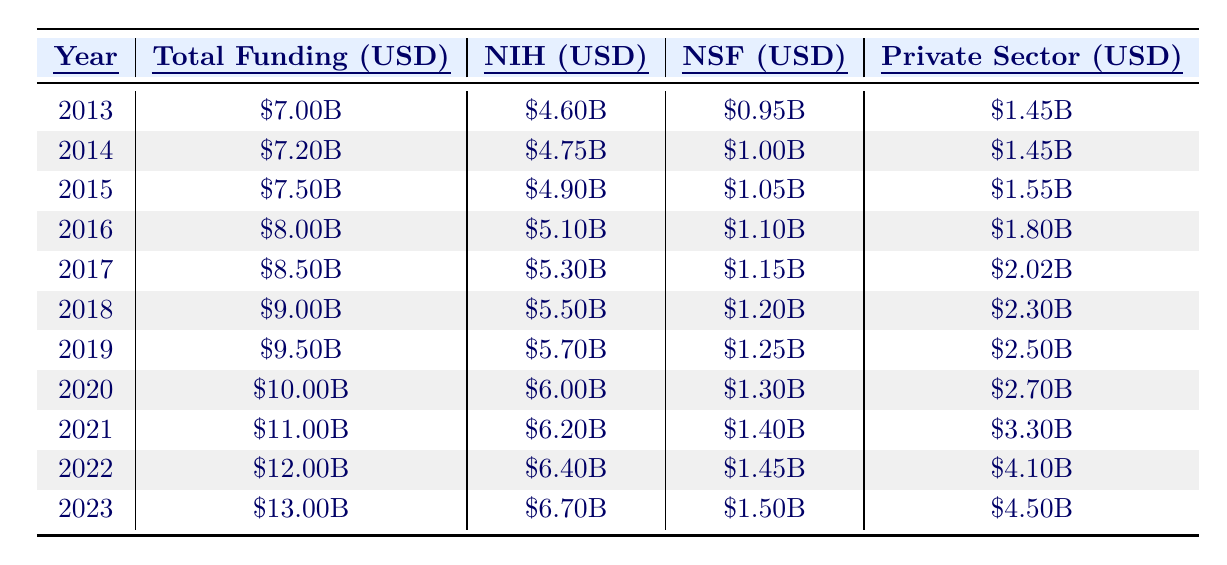What was the total funding for neuroscience research in 2015? The table shows that in 2015, the total funding was listed as \$7.50 billion.
Answer: \$7.50 billion Which funding source contributed the most in 2020? The NIH (National Institutes of Health) contributed \$6.00 billion in 2020, which is more than the contributions from NSF and the Private Sector.
Answer: NIH What is the percentage increase in total funding from 2013 to 2023? The total funding in 2013 was \$7.00 billion and in 2023 it is \$13.00 billion. The increase is \$13.00B - \$7.00B = \$6.00B. The percentage increase is (\$6.00B / \$7.00B) * 100 = 85.71%.
Answer: 85.71% In which year did the Private Sector funding exceed \$2 billion? The table indicates that Private Sector funding surpassed \$2 billion for the first time in 2017, as the amounts for years before that were below \$2 billion.
Answer: 2017 What was the average total funding over the 11 years from 2013 to 2023? The sum of total funding from 2013 to 2023 is \$7.00B + \$7.20B + \$7.50B + \$8.00B + \$8.50B + \$9.00B + \$9.50B + \$10.00B + \$11.00B + \$12.00B + \$13.00B = \$98.70 billion. The average is \$98.70B / 11 ≈ \$8.97 billion.
Answer: Approximately \$8.97 billion Was there an increase in NIH funding from 2019 to 2022? Yes, NIH funding in 2019 was \$5.70 billion and in 2022 it increased to \$6.40 billion, indicating a positive change.
Answer: Yes What was the total amount funded by NSF in 2021 and 2022 combined? For 2021, NSF funding was \$1.40 billion, and for 2022 it was \$1.45 billion. The combined total is \$1.40B + \$1.45B = \$2.85 billion.
Answer: \$2.85 billion How much did total funding increase from 2021 to 2023? The total funding in 2021 was \$11.00 billion and in 2023 it is \$13.00 billion. The increase is \$13.00B - \$11.00B = \$2.00B.
Answer: \$2.00 billion Which year had the highest contribution from the Private Sector, and what was the amount? The year 2023 had the highest Private Sector contribution of \$4.50 billion. Prior years had lower amounts.
Answer: 2023, \$4.50 billion What is the average funding from the NIH over the years 2013 to 2023? The NIH funding amounts are \$4.60B, \$4.75B, \$4.90B, \$5.10B, \$5.30B, \$5.50B, \$5.70B, \$6.00B, \$6.20B, \$6.40B, and \$6.70B, summing to \$57.10B. The average is \$57.10B / 11 ≈ \$5.19 billion.
Answer: Approximately \$5.19 billion Did NSF's funding ever drop compared to the previous year during the decade? No, NSF's funding shows a steady increase from year to year from 2013 to 2023 and does not drop below the previous year’s funding.
Answer: No 